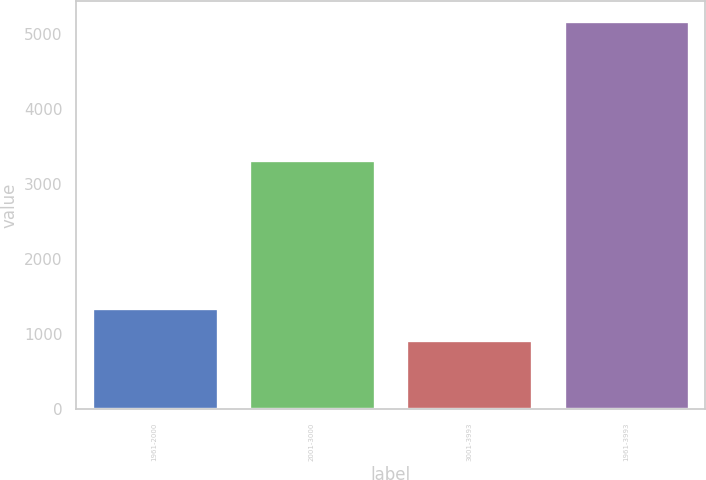<chart> <loc_0><loc_0><loc_500><loc_500><bar_chart><fcel>1961-2000<fcel>2001-3000<fcel>3001-3993<fcel>1961-3993<nl><fcel>1344.7<fcel>3321<fcel>919<fcel>5176<nl></chart> 